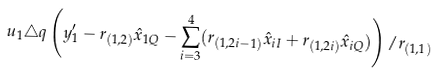Convert formula to latex. <formula><loc_0><loc_0><loc_500><loc_500>u _ { 1 } \triangle q \left ( y _ { 1 } ^ { \prime } - r _ { ( 1 , 2 ) } \hat { x } _ { 1 Q } - \sum _ { i = 3 } ^ { 4 } ( r _ { ( 1 , 2 i - 1 ) } \hat { x } _ { i I } + r _ { ( 1 , 2 i ) } \hat { x } _ { i Q } ) \right ) / r _ { ( 1 , 1 ) }</formula> 